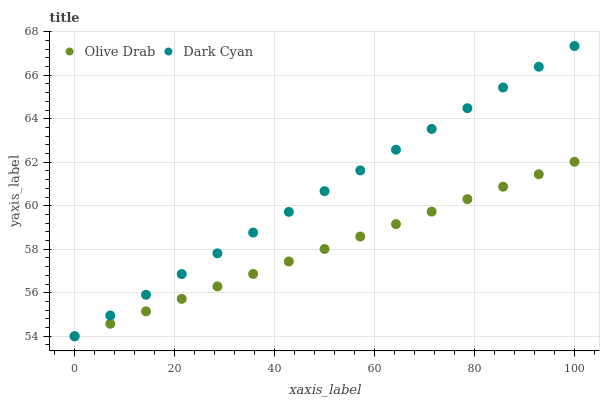Does Olive Drab have the minimum area under the curve?
Answer yes or no. Yes. Does Dark Cyan have the maximum area under the curve?
Answer yes or no. Yes. Does Olive Drab have the maximum area under the curve?
Answer yes or no. No. Is Olive Drab the smoothest?
Answer yes or no. Yes. Is Dark Cyan the roughest?
Answer yes or no. Yes. Is Olive Drab the roughest?
Answer yes or no. No. Does Dark Cyan have the lowest value?
Answer yes or no. Yes. Does Dark Cyan have the highest value?
Answer yes or no. Yes. Does Olive Drab have the highest value?
Answer yes or no. No. Does Olive Drab intersect Dark Cyan?
Answer yes or no. Yes. Is Olive Drab less than Dark Cyan?
Answer yes or no. No. Is Olive Drab greater than Dark Cyan?
Answer yes or no. No. 